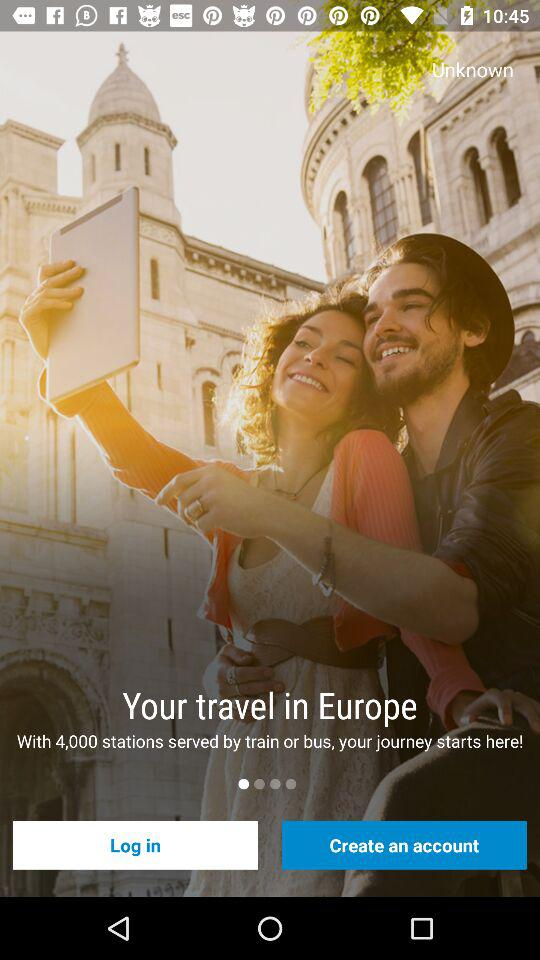What is the current location for travel?
When the provided information is insufficient, respond with <no answer>. <no answer> 